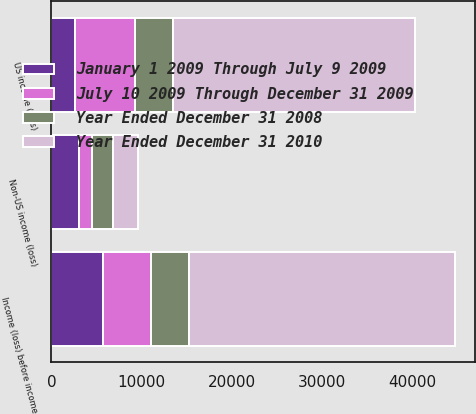Convert chart to OTSL. <chart><loc_0><loc_0><loc_500><loc_500><stacked_bar_chart><ecel><fcel>US income (loss)<fcel>Non-US income (loss)<fcel>Income (loss) before income<nl><fcel>January 1 2009 Through July 9 2009<fcel>2648<fcel>3089<fcel>5737<nl><fcel>July 10 2009 Through December 31 2009<fcel>6647<fcel>1364<fcel>5283<nl><fcel>Year Ended December 31 2008<fcel>4186<fcel>2356<fcel>4186<nl><fcel>Year Ended December 31 2010<fcel>26742<fcel>2729<fcel>29471<nl></chart> 